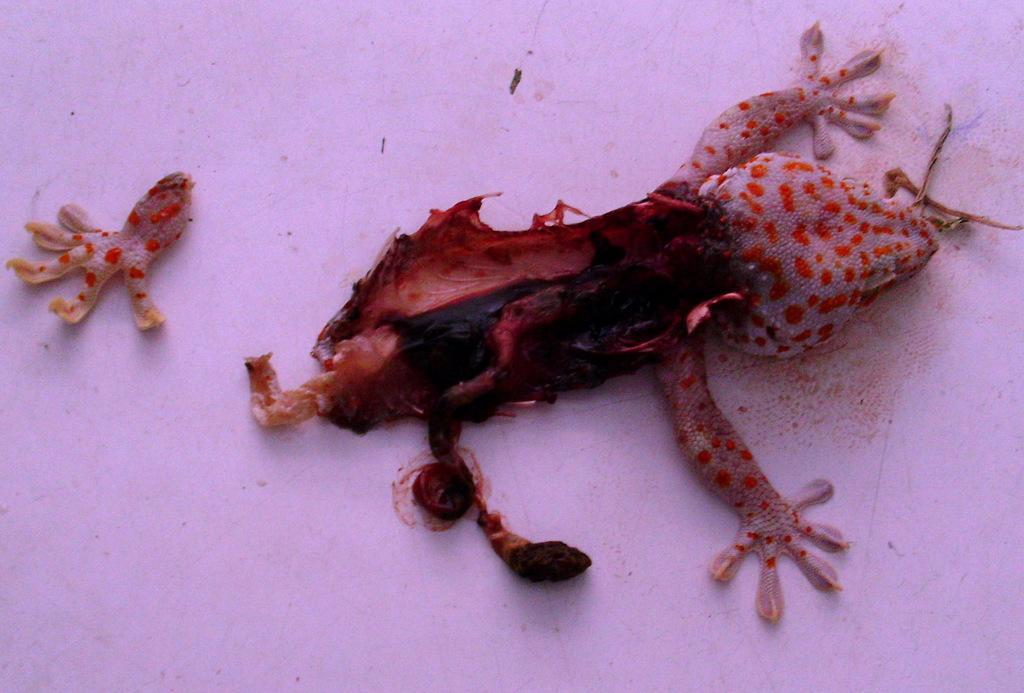Could you give a brief overview of what you see in this image? There is a lizard. Which is partially broken on the white color floor, near a broken leg of it. The background is white in color. 